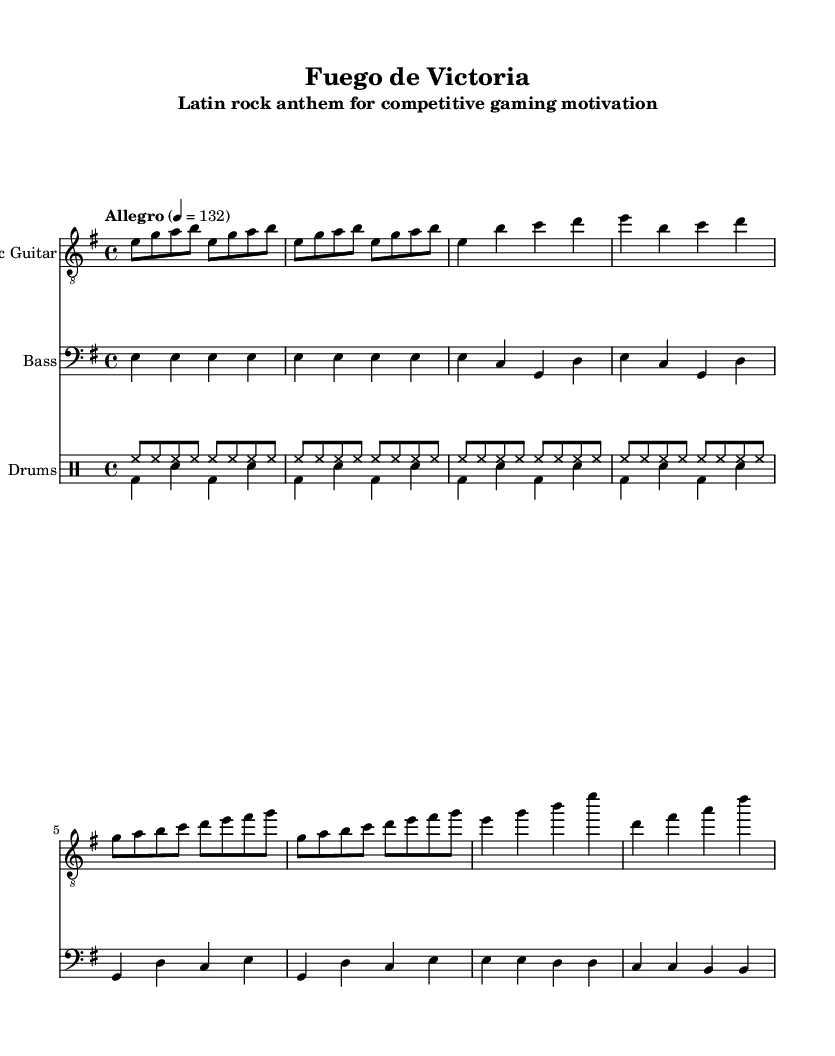What is the key signature of this music? The key signature is E minor, which has one sharp (F#). This can be seen at the beginning of the score where the key signature is indicated.
Answer: E minor What is the time signature of this music? The time signature is 4/4, as shown at the beginning of the score. This means there are four beats in each measure.
Answer: 4/4 What is the tempo indicated for this piece? The tempo is marked as "Allegro" with a metronome marking of quarter note equals 132. This can be found in the tempo marking at the start of the score.
Answer: Allegro, 132 How many measures are there in the chorus section? The chorus section contains 2 measures, as indicated by the music notation in the score. By counting the measures from the chorus section specifically, we see there are 2 written.
Answer: 2 What instruments are featured in this score? The score features an electric guitar, bass guitar, and drums. This information is found in the instrument labeling at the beginning of each staff.
Answer: Electric guitar, bass, drums What type of rhythm is predominantly used in the drums part? The predominant rhythm is a steady eighth-note pattern for the hi-hat, providing a consistent groove. This can be analyzed by looking at the drum part where the hi-hat is played in a regular, repeating manner.
Answer: Eighth notes 